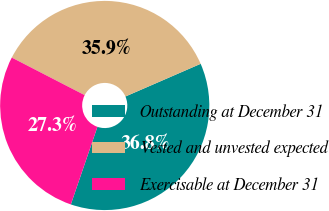Convert chart to OTSL. <chart><loc_0><loc_0><loc_500><loc_500><pie_chart><fcel>Outstanding at December 31<fcel>Vested and unvested expected<fcel>Exercisable at December 31<nl><fcel>36.78%<fcel>35.9%<fcel>27.32%<nl></chart> 